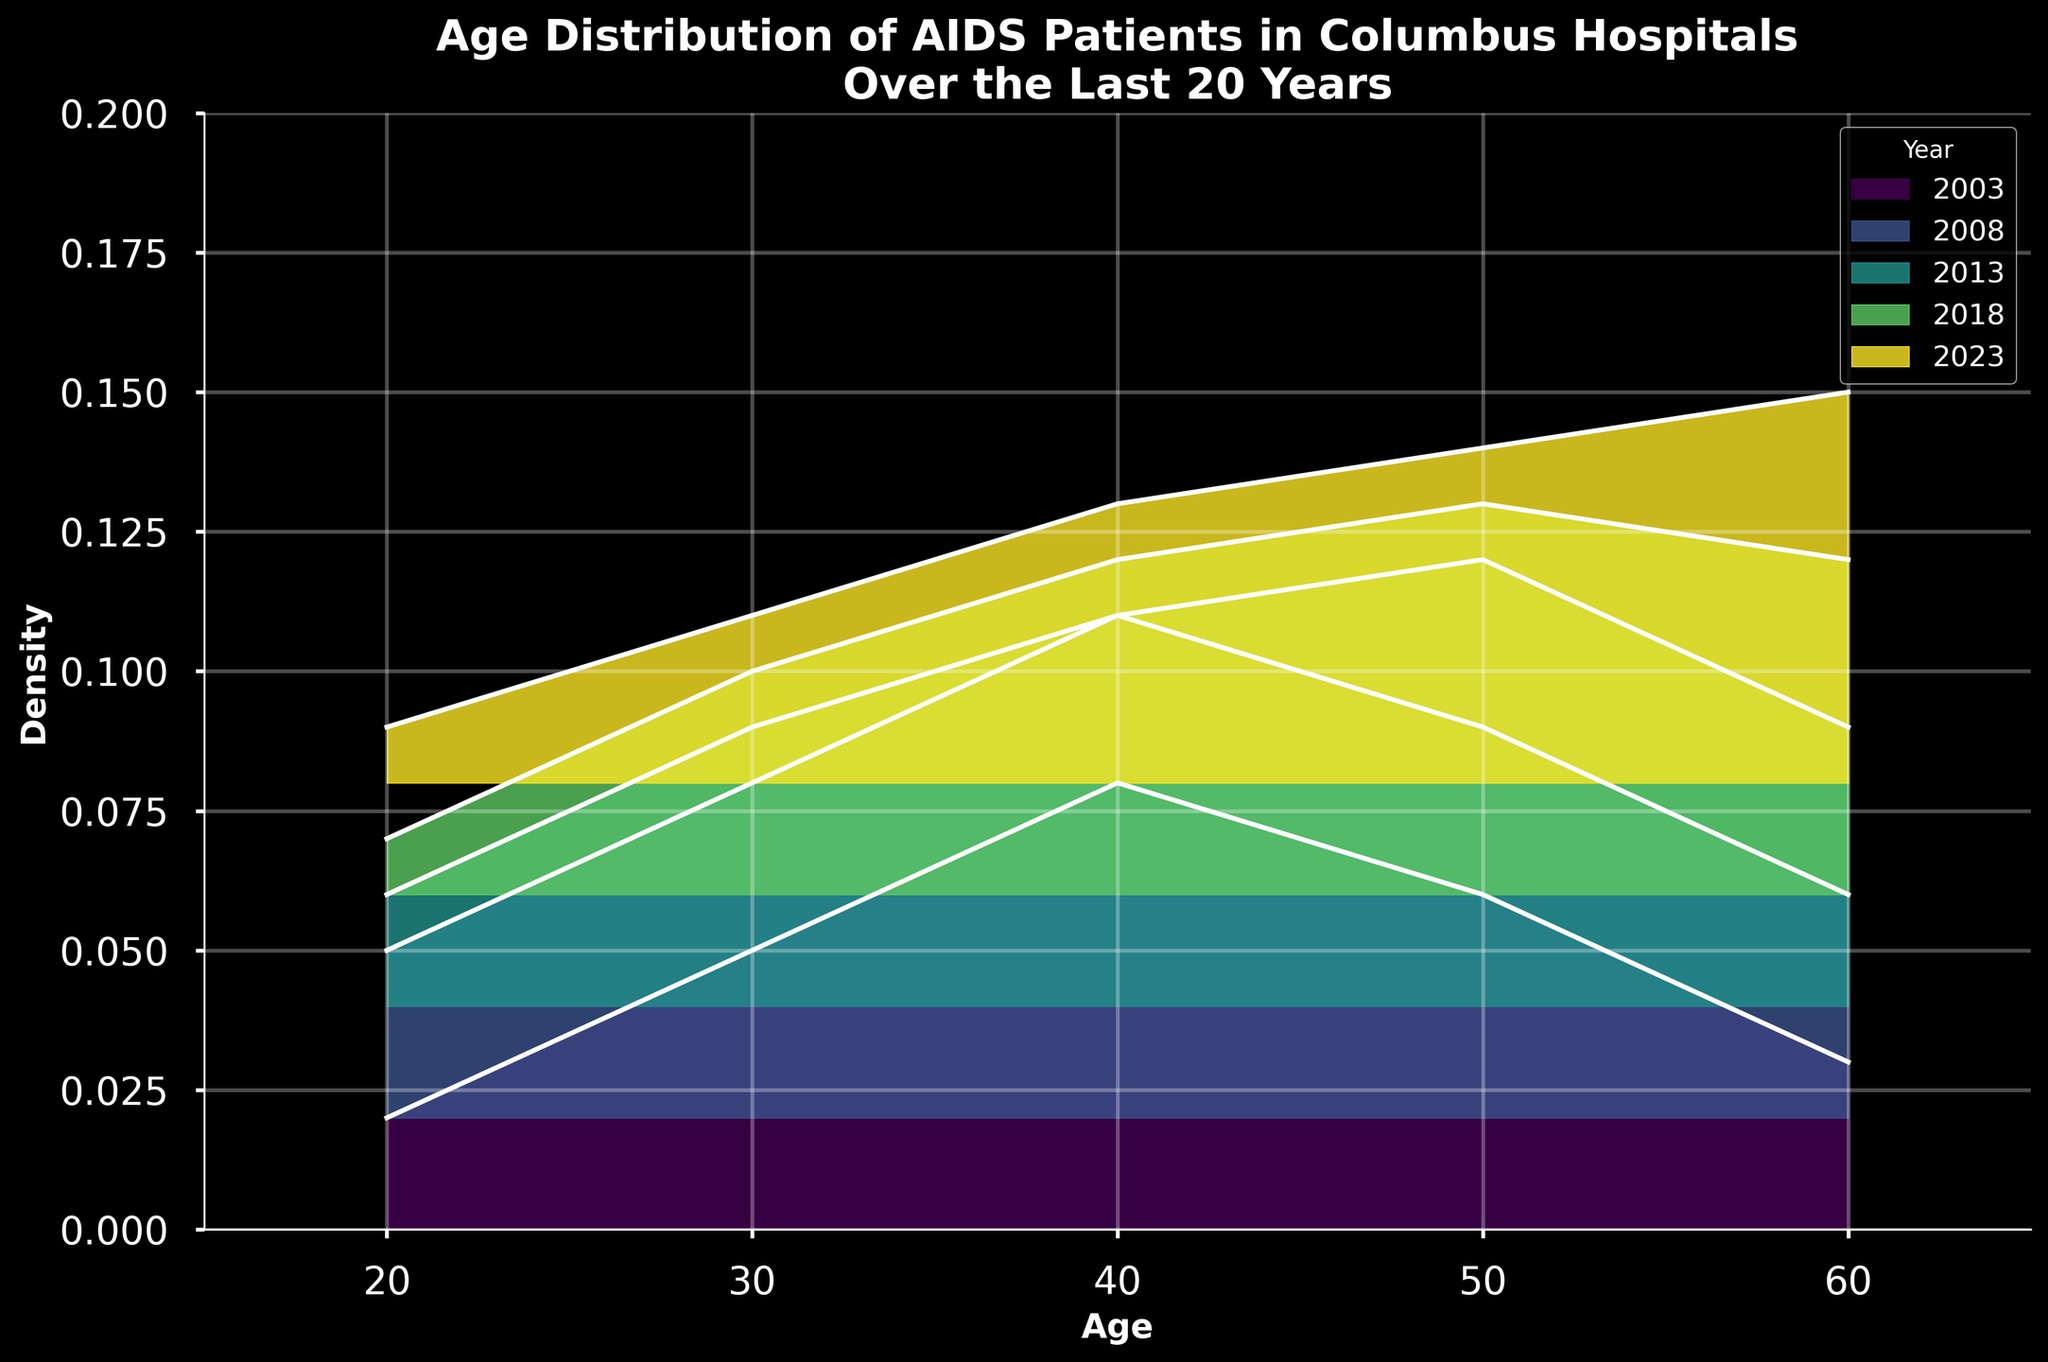what is the title of the plot? The title is prominently displayed at the top of the figure. It reads "Age Distribution of AIDS Patients in Columbus Hospitals Over the Last 20 Years".
Answer: Age Distribution of AIDS Patients in Columbus Hospitals Over the Last 20 Years What is the overall trend in the age group with the highest density over the 20 years? Reviewing the figure, each year depicts different density peaks. Initially, the 40-year age group seems to have the highest density, but over time, the 50 and then 60-year age groups' densities increase. This suggests an aging population of AIDS patients.
Answer: Aging population of AIDS patients What is the color used for the year 2003 in the ridgeline plot? By examining the ridgeline plot, we can observe the specific color used for the year 2003. It is towards the start of the color gradient and appears as a dark shade close to purple.
Answer: Dark shade of purple How does the density of the 50-year age group in 2018 compare to that in 2003? Looking at the density lines for the 50-year age group, in 2003 it is at a density of 0.06, and in 2018 it is at a density of 0.07. So, the density slightly increased from 2003 to 2018.
Answer: Increased Which year shows the highest density for patients aged 60? Examining the density peaks for patients aged 60 across the years, in 2023, the density for this age group is highest compared to other years. The density value in 2023 for the 60-year age group is clearly higher than in previous years.
Answer: 2023 What is the main visual trend observed across all age groups in the last 20 years? The plot shows that while younger age groups (20-30) have seen a decrease in density, older age groups (especially 50-60) have seen an increase, indicating a trend of aging AIDS patients.
Answer: Aging AIDS patients trend How does the density distribution in 2008 compare to that in 2013 for the 30-year-old age group? In 2008, the density for the 30-year-old age group is 0.06, while in 2013, it is slightly lower at 0.05. By comparing these two values, the density decreased slightly over this period.
Answer: Decreased What range of ages is covered in the ridgeline plot? By looking at the x-axis, we can see that the age range covered in the plot is from 20 to 60 years. This can be confirmed by checking the age labels on the plot.
Answer: 20 to 60 years What is the primary observation about density changes for the 40-year age group from 2003 to 2023? Observing the plot, the 40-year age group's density starts at 0.08 in 2003 and decreases to 0.05 in 2023. This indicates a reduction in density over the 20-year period.
Answer: Decrease How is the density distribution across ages in the latest year (2023) compared to the previous years? The density distribution in 2023 shows a higher density for the 60-year age group compared to previous years. The younger age groups (20s and 30s) have lower densities, implying more older patients than before.
Answer: Higher density in older age groups 